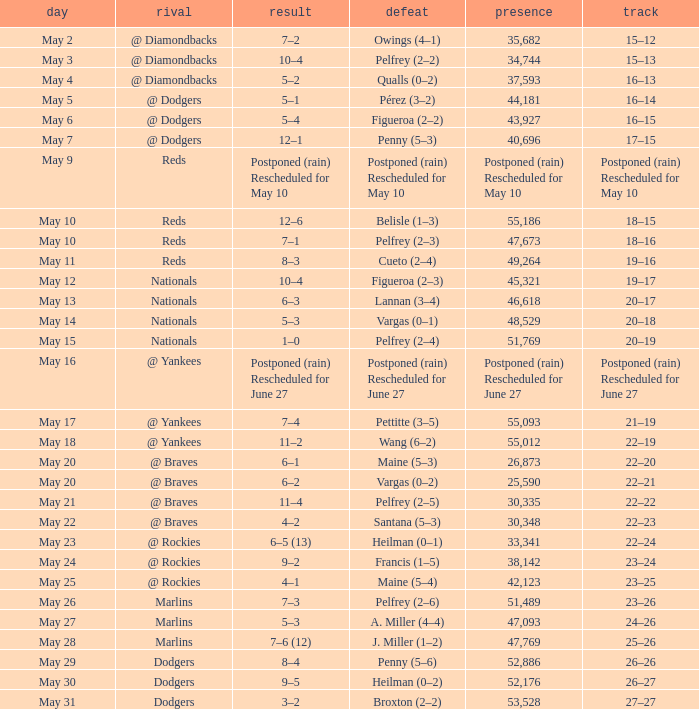Attendance of 30,335 had what record? 22–22. 